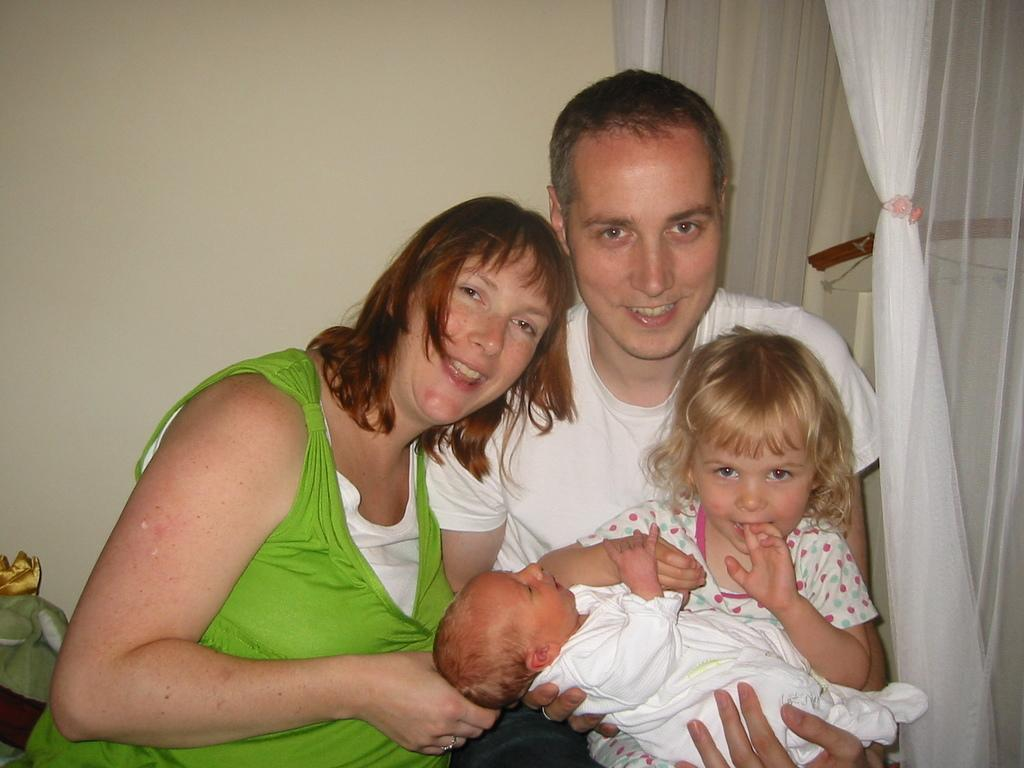How many people are in the image? There are persons in the image, but the exact number cannot be determined from the provided facts. What is the background of the image? There is a wall visible in the image, which suggests a room or interior setting. What type of window treatment is present in the image? There is a curtain in the image, which may be used for privacy or decoration. Can you describe the object in the bottom left of the image? Unfortunately, the provided facts do not give enough information to describe the object in the bottom left of the image. What type of bun is being used to transport the hour in the image? There is no bun, transportation, or hour present in the image. 